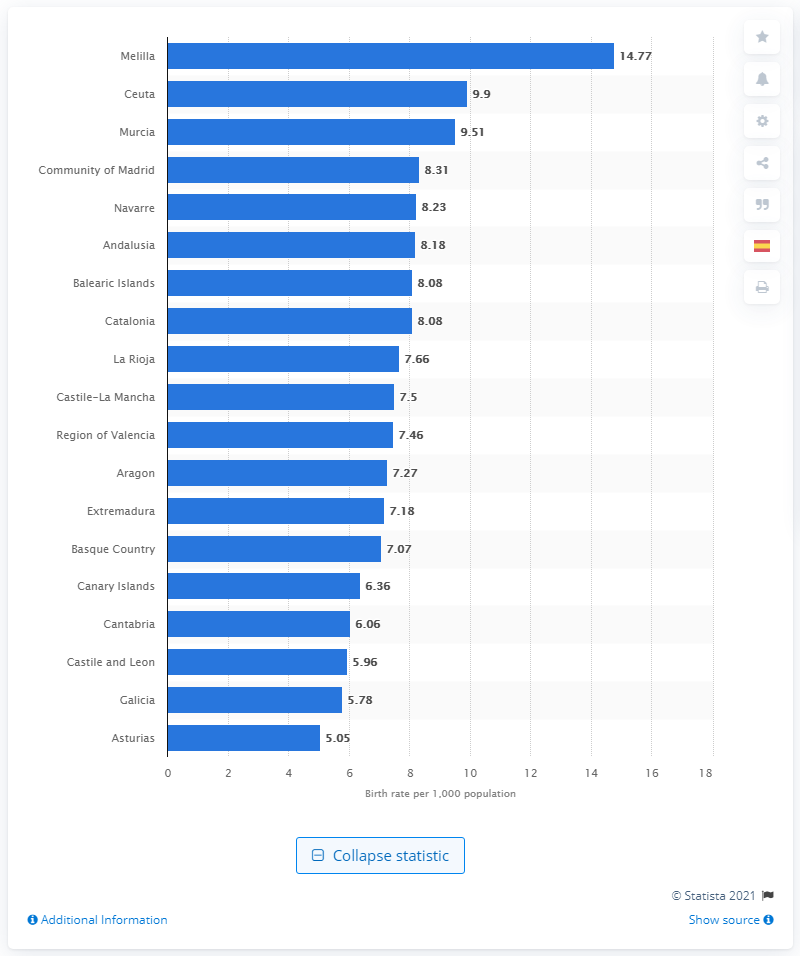Draw attention to some important aspects in this diagram. Asturias was the Spanish city with the lowest birth rate in 2019. Andalusia was the most populous autonomous community in Spain as of January 2019. According to data from 2019, the Spanish city of Melilla had the highest birth rate among all Spanish cities. 